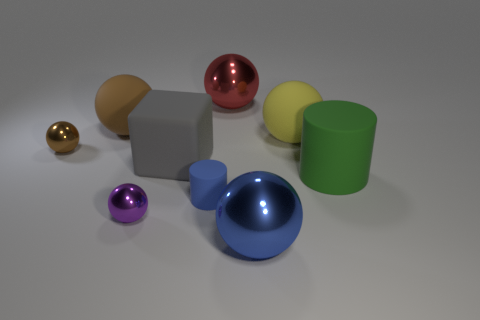Subtract all yellow balls. How many balls are left? 5 Subtract all brown matte balls. How many balls are left? 5 Subtract all brown cylinders. Subtract all purple spheres. How many cylinders are left? 2 Add 1 red shiny spheres. How many objects exist? 10 Subtract all spheres. How many objects are left? 3 Subtract all purple spheres. Subtract all small red shiny cylinders. How many objects are left? 8 Add 5 cylinders. How many cylinders are left? 7 Add 7 purple cylinders. How many purple cylinders exist? 7 Subtract 1 purple balls. How many objects are left? 8 